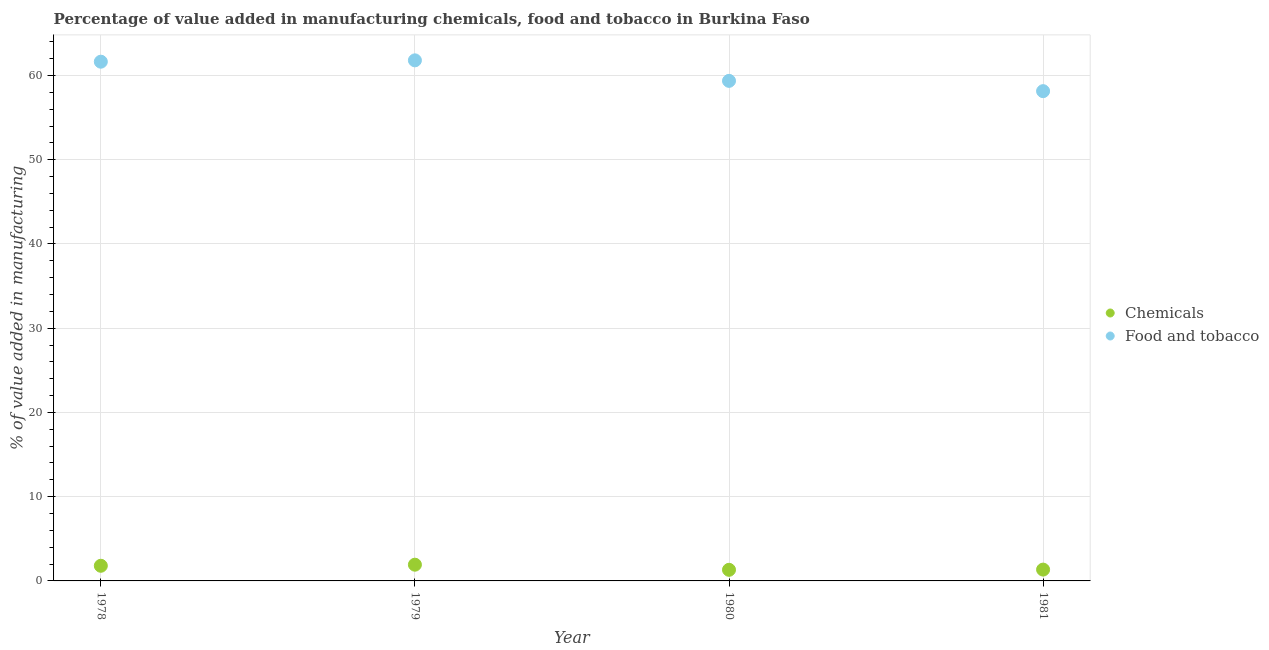Is the number of dotlines equal to the number of legend labels?
Give a very brief answer. Yes. What is the value added by  manufacturing chemicals in 1979?
Ensure brevity in your answer.  1.93. Across all years, what is the maximum value added by manufacturing food and tobacco?
Provide a succinct answer. 61.8. Across all years, what is the minimum value added by  manufacturing chemicals?
Provide a succinct answer. 1.32. In which year was the value added by  manufacturing chemicals maximum?
Your response must be concise. 1979. What is the total value added by manufacturing food and tobacco in the graph?
Ensure brevity in your answer.  240.96. What is the difference between the value added by manufacturing food and tobacco in 1978 and that in 1980?
Make the answer very short. 2.28. What is the difference between the value added by manufacturing food and tobacco in 1979 and the value added by  manufacturing chemicals in 1981?
Provide a succinct answer. 60.46. What is the average value added by  manufacturing chemicals per year?
Your answer should be compact. 1.6. In the year 1981, what is the difference between the value added by manufacturing food and tobacco and value added by  manufacturing chemicals?
Your answer should be compact. 56.8. What is the ratio of the value added by manufacturing food and tobacco in 1979 to that in 1981?
Your answer should be very brief. 1.06. Is the difference between the value added by  manufacturing chemicals in 1978 and 1979 greater than the difference between the value added by manufacturing food and tobacco in 1978 and 1979?
Your response must be concise. Yes. What is the difference between the highest and the second highest value added by  manufacturing chemicals?
Provide a succinct answer. 0.13. What is the difference between the highest and the lowest value added by  manufacturing chemicals?
Provide a short and direct response. 0.61. Is the sum of the value added by  manufacturing chemicals in 1980 and 1981 greater than the maximum value added by manufacturing food and tobacco across all years?
Your response must be concise. No. Does the value added by  manufacturing chemicals monotonically increase over the years?
Your answer should be very brief. No. How many dotlines are there?
Give a very brief answer. 2. How many years are there in the graph?
Provide a short and direct response. 4. Are the values on the major ticks of Y-axis written in scientific E-notation?
Ensure brevity in your answer.  No. Where does the legend appear in the graph?
Your answer should be very brief. Center right. How are the legend labels stacked?
Give a very brief answer. Vertical. What is the title of the graph?
Keep it short and to the point. Percentage of value added in manufacturing chemicals, food and tobacco in Burkina Faso. What is the label or title of the Y-axis?
Your answer should be compact. % of value added in manufacturing. What is the % of value added in manufacturing in Chemicals in 1978?
Your answer should be compact. 1.8. What is the % of value added in manufacturing of Food and tobacco in 1978?
Provide a short and direct response. 61.64. What is the % of value added in manufacturing of Chemicals in 1979?
Offer a very short reply. 1.93. What is the % of value added in manufacturing of Food and tobacco in 1979?
Your answer should be compact. 61.8. What is the % of value added in manufacturing in Chemicals in 1980?
Give a very brief answer. 1.32. What is the % of value added in manufacturing of Food and tobacco in 1980?
Offer a very short reply. 59.37. What is the % of value added in manufacturing of Chemicals in 1981?
Make the answer very short. 1.34. What is the % of value added in manufacturing of Food and tobacco in 1981?
Provide a short and direct response. 58.15. Across all years, what is the maximum % of value added in manufacturing of Chemicals?
Your response must be concise. 1.93. Across all years, what is the maximum % of value added in manufacturing of Food and tobacco?
Your response must be concise. 61.8. Across all years, what is the minimum % of value added in manufacturing of Chemicals?
Offer a very short reply. 1.32. Across all years, what is the minimum % of value added in manufacturing of Food and tobacco?
Ensure brevity in your answer.  58.15. What is the total % of value added in manufacturing in Chemicals in the graph?
Ensure brevity in your answer.  6.39. What is the total % of value added in manufacturing in Food and tobacco in the graph?
Ensure brevity in your answer.  240.96. What is the difference between the % of value added in manufacturing in Chemicals in 1978 and that in 1979?
Provide a succinct answer. -0.13. What is the difference between the % of value added in manufacturing of Food and tobacco in 1978 and that in 1979?
Provide a succinct answer. -0.16. What is the difference between the % of value added in manufacturing of Chemicals in 1978 and that in 1980?
Offer a terse response. 0.48. What is the difference between the % of value added in manufacturing of Food and tobacco in 1978 and that in 1980?
Keep it short and to the point. 2.28. What is the difference between the % of value added in manufacturing of Chemicals in 1978 and that in 1981?
Keep it short and to the point. 0.45. What is the difference between the % of value added in manufacturing of Food and tobacco in 1978 and that in 1981?
Your answer should be very brief. 3.5. What is the difference between the % of value added in manufacturing of Chemicals in 1979 and that in 1980?
Your answer should be very brief. 0.61. What is the difference between the % of value added in manufacturing of Food and tobacco in 1979 and that in 1980?
Give a very brief answer. 2.44. What is the difference between the % of value added in manufacturing in Chemicals in 1979 and that in 1981?
Ensure brevity in your answer.  0.58. What is the difference between the % of value added in manufacturing of Food and tobacco in 1979 and that in 1981?
Your answer should be very brief. 3.66. What is the difference between the % of value added in manufacturing in Chemicals in 1980 and that in 1981?
Keep it short and to the point. -0.03. What is the difference between the % of value added in manufacturing of Food and tobacco in 1980 and that in 1981?
Give a very brief answer. 1.22. What is the difference between the % of value added in manufacturing in Chemicals in 1978 and the % of value added in manufacturing in Food and tobacco in 1979?
Your answer should be very brief. -60.01. What is the difference between the % of value added in manufacturing in Chemicals in 1978 and the % of value added in manufacturing in Food and tobacco in 1980?
Give a very brief answer. -57.57. What is the difference between the % of value added in manufacturing in Chemicals in 1978 and the % of value added in manufacturing in Food and tobacco in 1981?
Keep it short and to the point. -56.35. What is the difference between the % of value added in manufacturing in Chemicals in 1979 and the % of value added in manufacturing in Food and tobacco in 1980?
Give a very brief answer. -57.44. What is the difference between the % of value added in manufacturing of Chemicals in 1979 and the % of value added in manufacturing of Food and tobacco in 1981?
Provide a short and direct response. -56.22. What is the difference between the % of value added in manufacturing of Chemicals in 1980 and the % of value added in manufacturing of Food and tobacco in 1981?
Your response must be concise. -56.83. What is the average % of value added in manufacturing of Chemicals per year?
Your response must be concise. 1.6. What is the average % of value added in manufacturing of Food and tobacco per year?
Offer a terse response. 60.24. In the year 1978, what is the difference between the % of value added in manufacturing in Chemicals and % of value added in manufacturing in Food and tobacco?
Provide a short and direct response. -59.85. In the year 1979, what is the difference between the % of value added in manufacturing in Chemicals and % of value added in manufacturing in Food and tobacco?
Offer a very short reply. -59.88. In the year 1980, what is the difference between the % of value added in manufacturing of Chemicals and % of value added in manufacturing of Food and tobacco?
Offer a very short reply. -58.05. In the year 1981, what is the difference between the % of value added in manufacturing of Chemicals and % of value added in manufacturing of Food and tobacco?
Ensure brevity in your answer.  -56.8. What is the ratio of the % of value added in manufacturing in Chemicals in 1978 to that in 1979?
Keep it short and to the point. 0.93. What is the ratio of the % of value added in manufacturing in Chemicals in 1978 to that in 1980?
Keep it short and to the point. 1.36. What is the ratio of the % of value added in manufacturing in Food and tobacco in 1978 to that in 1980?
Offer a very short reply. 1.04. What is the ratio of the % of value added in manufacturing of Chemicals in 1978 to that in 1981?
Give a very brief answer. 1.34. What is the ratio of the % of value added in manufacturing of Food and tobacco in 1978 to that in 1981?
Offer a very short reply. 1.06. What is the ratio of the % of value added in manufacturing in Chemicals in 1979 to that in 1980?
Offer a very short reply. 1.46. What is the ratio of the % of value added in manufacturing in Food and tobacco in 1979 to that in 1980?
Provide a succinct answer. 1.04. What is the ratio of the % of value added in manufacturing of Chemicals in 1979 to that in 1981?
Your response must be concise. 1.43. What is the ratio of the % of value added in manufacturing in Food and tobacco in 1979 to that in 1981?
Offer a very short reply. 1.06. What is the ratio of the % of value added in manufacturing in Chemicals in 1980 to that in 1981?
Your answer should be compact. 0.98. What is the ratio of the % of value added in manufacturing in Food and tobacco in 1980 to that in 1981?
Make the answer very short. 1.02. What is the difference between the highest and the second highest % of value added in manufacturing of Chemicals?
Offer a very short reply. 0.13. What is the difference between the highest and the second highest % of value added in manufacturing of Food and tobacco?
Offer a very short reply. 0.16. What is the difference between the highest and the lowest % of value added in manufacturing in Chemicals?
Offer a terse response. 0.61. What is the difference between the highest and the lowest % of value added in manufacturing of Food and tobacco?
Keep it short and to the point. 3.66. 